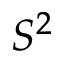Convert formula to latex. <formula><loc_0><loc_0><loc_500><loc_500>S ^ { 2 }</formula> 